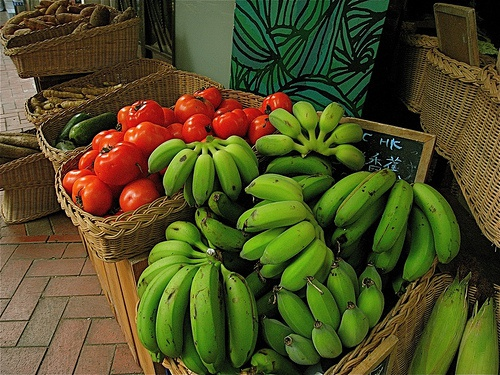Describe the objects in this image and their specific colors. I can see a banana in gray, black, olive, and darkgreen tones in this image. 